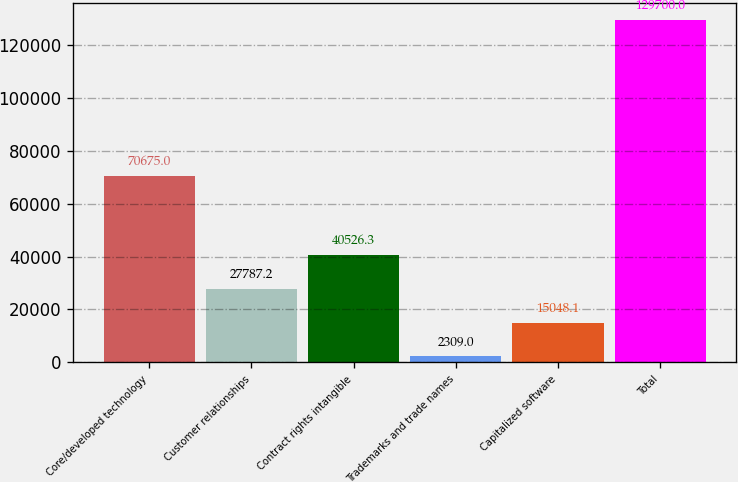Convert chart to OTSL. <chart><loc_0><loc_0><loc_500><loc_500><bar_chart><fcel>Core/developed technology<fcel>Customer relationships<fcel>Contract rights intangible<fcel>Trademarks and trade names<fcel>Capitalized software<fcel>Total<nl><fcel>70675<fcel>27787.2<fcel>40526.3<fcel>2309<fcel>15048.1<fcel>129700<nl></chart> 